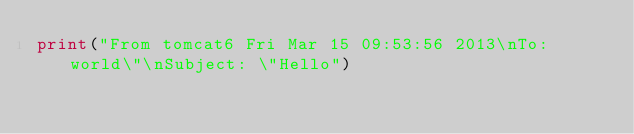<code> <loc_0><loc_0><loc_500><loc_500><_Python_>print("From tomcat6 Fri Mar 15 09:53:56 2013\nTo: world\"\nSubject: \"Hello")
</code> 